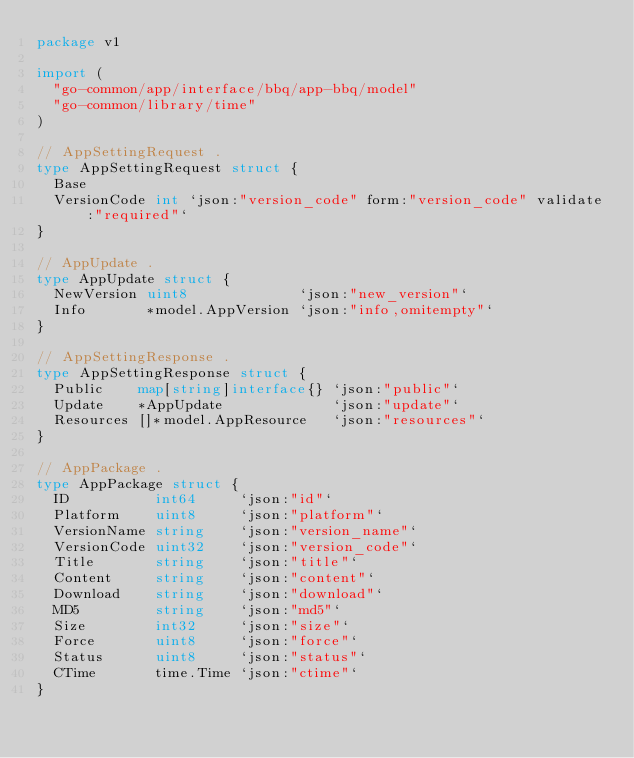Convert code to text. <code><loc_0><loc_0><loc_500><loc_500><_Go_>package v1

import (
	"go-common/app/interface/bbq/app-bbq/model"
	"go-common/library/time"
)

// AppSettingRequest .
type AppSettingRequest struct {
	Base
	VersionCode int `json:"version_code" form:"version_code" validate:"required"`
}

// AppUpdate .
type AppUpdate struct {
	NewVersion uint8             `json:"new_version"`
	Info       *model.AppVersion `json:"info,omitempty"`
}

// AppSettingResponse .
type AppSettingResponse struct {
	Public    map[string]interface{} `json:"public"`
	Update    *AppUpdate             `json:"update"`
	Resources []*model.AppResource   `json:"resources"`
}

// AppPackage .
type AppPackage struct {
	ID          int64     `json:"id"`
	Platform    uint8     `json:"platform"`
	VersionName string    `json:"version_name"`
	VersionCode uint32    `json:"version_code"`
	Title       string    `json:"title"`
	Content     string    `json:"content"`
	Download    string    `json:"download"`
	MD5         string    `json:"md5"`
	Size        int32     `json:"size"`
	Force       uint8     `json:"force"`
	Status      uint8     `json:"status"`
	CTime       time.Time `json:"ctime"`
}
</code> 